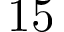<formula> <loc_0><loc_0><loc_500><loc_500>1 5</formula> 